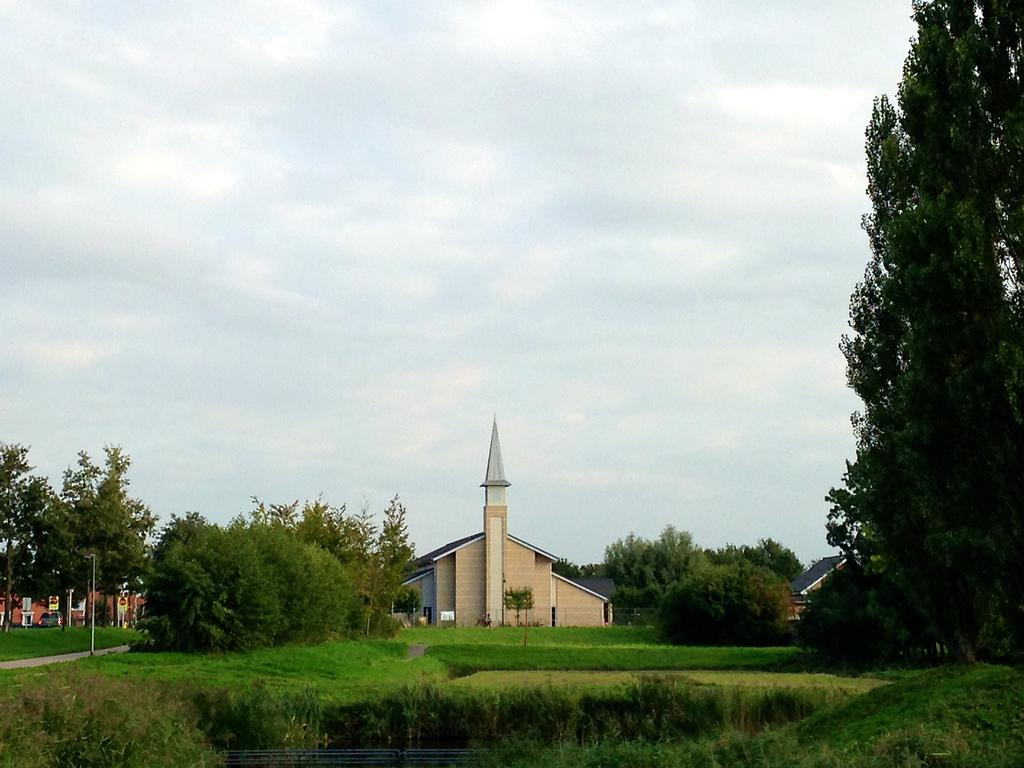What is the main structure in the middle of the image? There is a house in the middle of the image. What type of vegetation can be seen in the image? There are green trees in the image. How would you describe the sky in the image? The sky is cloudy in the image. How many ladybugs are crawling on the edge of the house in the image? There are no ladybugs present in the image, so it is not possible to determine how many there might be. 